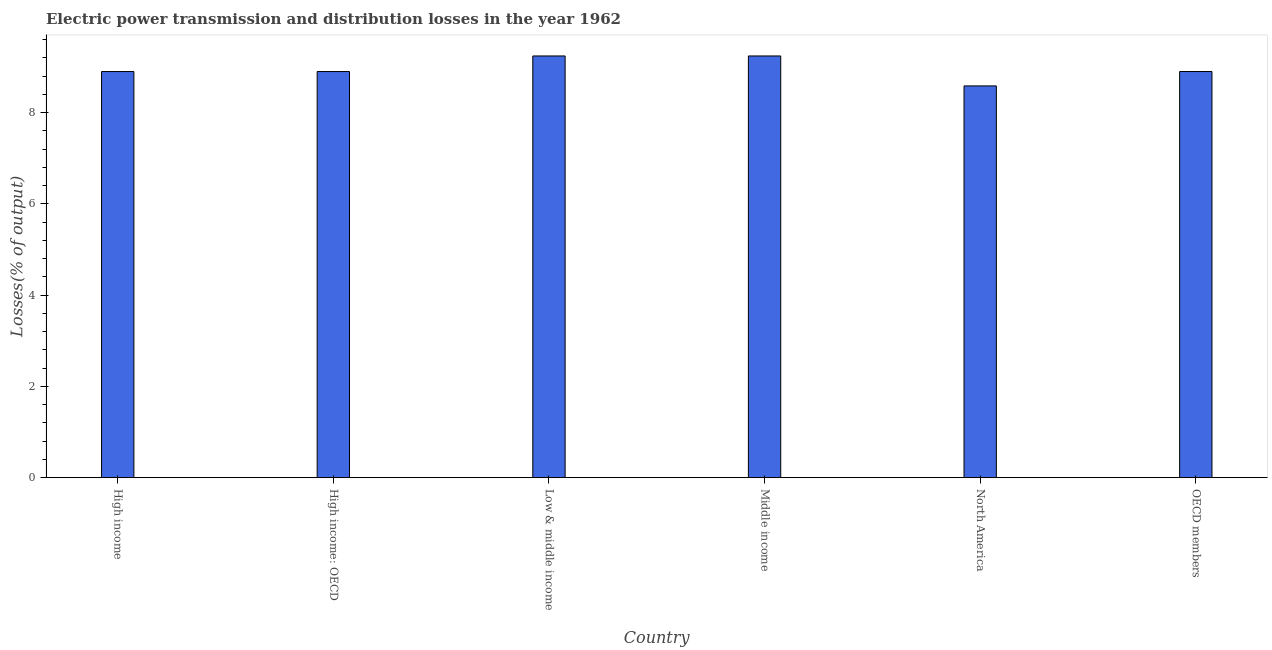Does the graph contain any zero values?
Your answer should be very brief. No. What is the title of the graph?
Ensure brevity in your answer.  Electric power transmission and distribution losses in the year 1962. What is the label or title of the Y-axis?
Provide a succinct answer. Losses(% of output). What is the electric power transmission and distribution losses in North America?
Give a very brief answer. 8.59. Across all countries, what is the maximum electric power transmission and distribution losses?
Keep it short and to the point. 9.24. Across all countries, what is the minimum electric power transmission and distribution losses?
Offer a very short reply. 8.59. In which country was the electric power transmission and distribution losses maximum?
Provide a succinct answer. Low & middle income. What is the sum of the electric power transmission and distribution losses?
Offer a terse response. 53.77. What is the difference between the electric power transmission and distribution losses in High income: OECD and North America?
Ensure brevity in your answer.  0.32. What is the average electric power transmission and distribution losses per country?
Your response must be concise. 8.96. What is the median electric power transmission and distribution losses?
Ensure brevity in your answer.  8.9. What is the ratio of the electric power transmission and distribution losses in High income: OECD to that in Middle income?
Keep it short and to the point. 0.96. Is the electric power transmission and distribution losses in High income: OECD less than that in North America?
Provide a succinct answer. No. Is the difference between the electric power transmission and distribution losses in High income and Low & middle income greater than the difference between any two countries?
Provide a short and direct response. No. Is the sum of the electric power transmission and distribution losses in High income: OECD and OECD members greater than the maximum electric power transmission and distribution losses across all countries?
Your response must be concise. Yes. What is the difference between the highest and the lowest electric power transmission and distribution losses?
Provide a short and direct response. 0.66. How many bars are there?
Offer a terse response. 6. How many countries are there in the graph?
Provide a short and direct response. 6. What is the difference between two consecutive major ticks on the Y-axis?
Keep it short and to the point. 2. What is the Losses(% of output) in High income?
Make the answer very short. 8.9. What is the Losses(% of output) in High income: OECD?
Make the answer very short. 8.9. What is the Losses(% of output) of Low & middle income?
Make the answer very short. 9.24. What is the Losses(% of output) in Middle income?
Offer a very short reply. 9.24. What is the Losses(% of output) in North America?
Provide a short and direct response. 8.59. What is the Losses(% of output) of OECD members?
Offer a terse response. 8.9. What is the difference between the Losses(% of output) in High income and Low & middle income?
Your answer should be compact. -0.34. What is the difference between the Losses(% of output) in High income and Middle income?
Ensure brevity in your answer.  -0.34. What is the difference between the Losses(% of output) in High income and North America?
Provide a short and direct response. 0.31. What is the difference between the Losses(% of output) in High income and OECD members?
Provide a succinct answer. -0. What is the difference between the Losses(% of output) in High income: OECD and Low & middle income?
Keep it short and to the point. -0.34. What is the difference between the Losses(% of output) in High income: OECD and Middle income?
Your response must be concise. -0.34. What is the difference between the Losses(% of output) in High income: OECD and North America?
Ensure brevity in your answer.  0.31. What is the difference between the Losses(% of output) in High income: OECD and OECD members?
Provide a succinct answer. -0. What is the difference between the Losses(% of output) in Low & middle income and North America?
Keep it short and to the point. 0.66. What is the difference between the Losses(% of output) in Low & middle income and OECD members?
Offer a very short reply. 0.34. What is the difference between the Losses(% of output) in Middle income and North America?
Keep it short and to the point. 0.66. What is the difference between the Losses(% of output) in Middle income and OECD members?
Your answer should be compact. 0.34. What is the difference between the Losses(% of output) in North America and OECD members?
Your response must be concise. -0.32. What is the ratio of the Losses(% of output) in High income to that in High income: OECD?
Offer a very short reply. 1. What is the ratio of the Losses(% of output) in High income to that in Middle income?
Your answer should be very brief. 0.96. What is the ratio of the Losses(% of output) in High income: OECD to that in Low & middle income?
Keep it short and to the point. 0.96. What is the ratio of the Losses(% of output) in High income: OECD to that in Middle income?
Your answer should be very brief. 0.96. What is the ratio of the Losses(% of output) in High income: OECD to that in North America?
Your answer should be compact. 1.04. What is the ratio of the Losses(% of output) in High income: OECD to that in OECD members?
Offer a very short reply. 1. What is the ratio of the Losses(% of output) in Low & middle income to that in Middle income?
Make the answer very short. 1. What is the ratio of the Losses(% of output) in Low & middle income to that in North America?
Give a very brief answer. 1.08. What is the ratio of the Losses(% of output) in Low & middle income to that in OECD members?
Provide a short and direct response. 1.04. What is the ratio of the Losses(% of output) in Middle income to that in North America?
Your answer should be compact. 1.08. What is the ratio of the Losses(% of output) in Middle income to that in OECD members?
Make the answer very short. 1.04. What is the ratio of the Losses(% of output) in North America to that in OECD members?
Give a very brief answer. 0.96. 